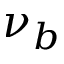Convert formula to latex. <formula><loc_0><loc_0><loc_500><loc_500>\nu _ { b }</formula> 